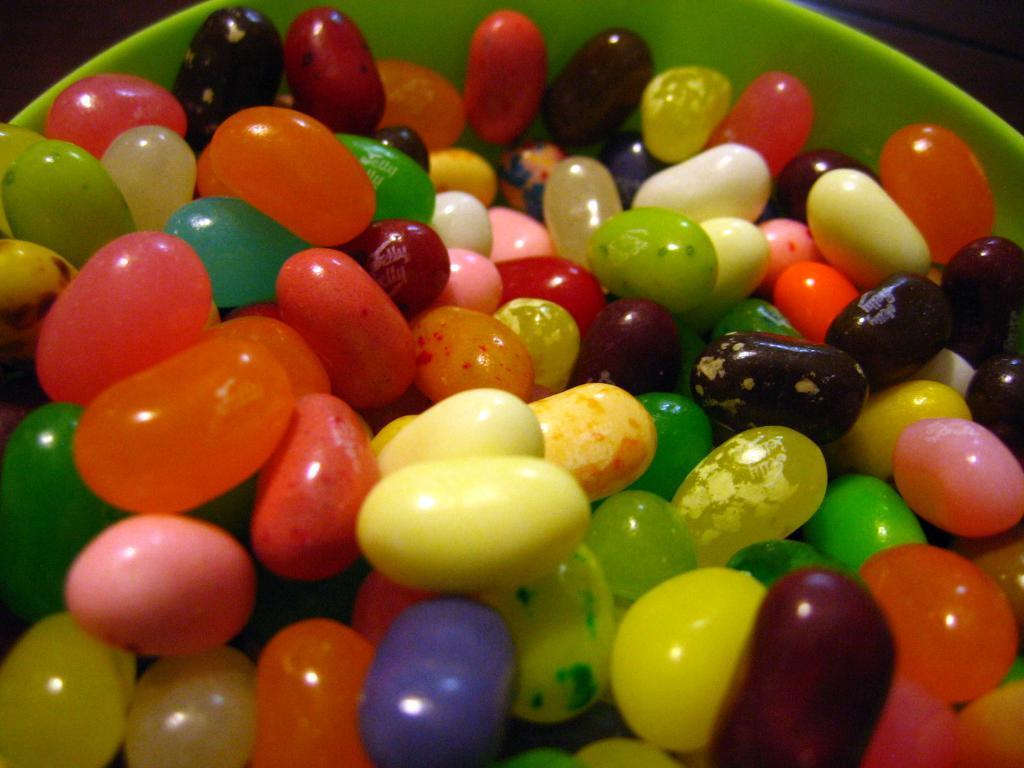Please provide a concise description of this image. In this image I can see colorful candies in a green color bowl. 